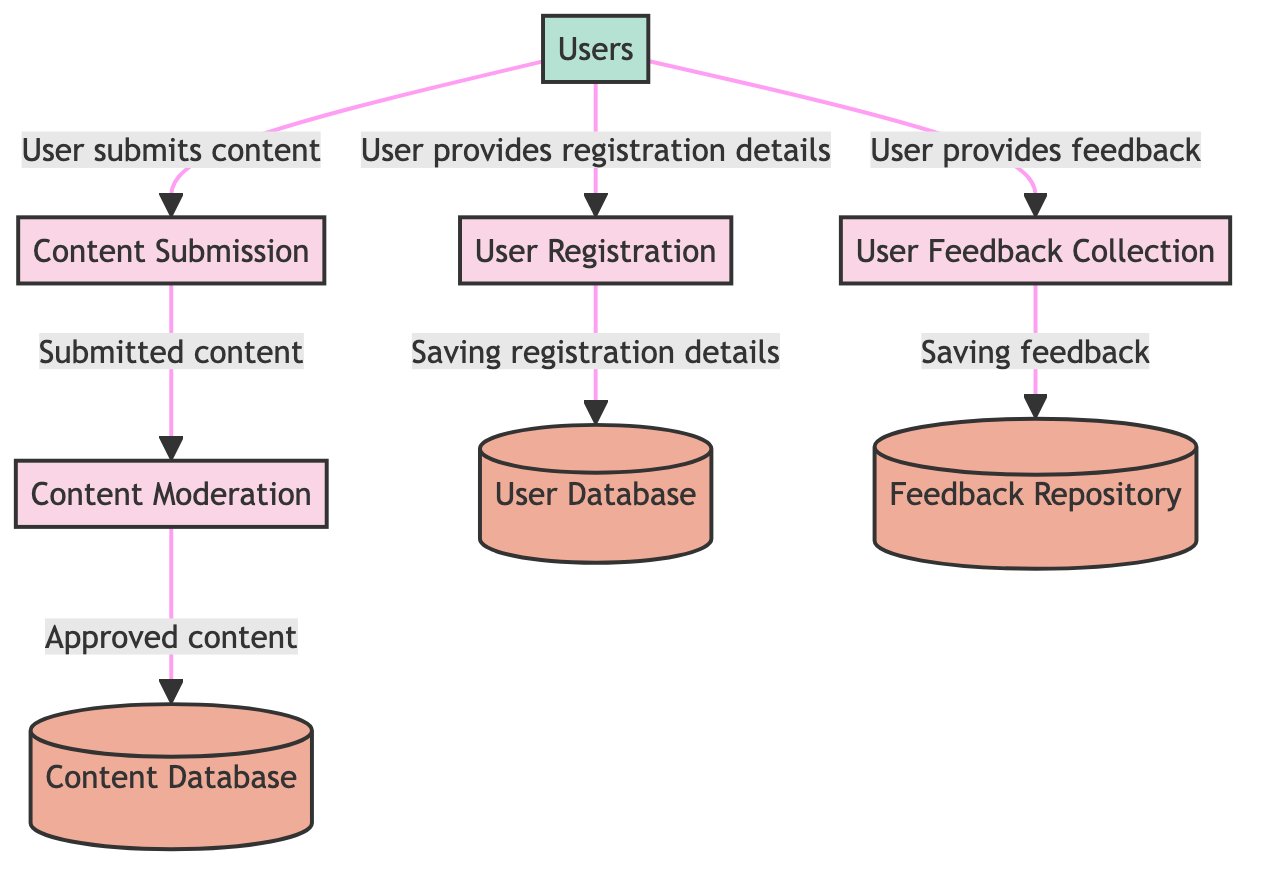What is the first process to occur in the diagram? The diagram starts with the "User Registration" process, which is the first action taken by new users who want to join the community. It is labeled as process 1 in the diagram.
Answer: User Registration How many data stores are present in the diagram? The diagram features three distinct data stores: User Database, Content Database, and Feedback Repository. This is identified by counting the labeled data store nodes.
Answer: 3 What flow represents the approval of content? The flow from "Content Moderation" to "Content Database" signifies the approval of content, where the moderated content gets stored once approved. This is indicated by the connection between these two processes in the diagram.
Answer: Approved content What type of information does the User Database store? The User Database stores user registration details, including usernames, passwords, emails, and profiles, as described in the data store section of the diagram.
Answer: User registration details What is the source of feedback collected in the User Feedback Collection process? The source of feedback in the "User Feedback Collection" process is the users, as they provide feedback directly into this process. This is indicated by the flow originating from the "Users" node leading to the process.
Answer: Users What happens to submitted content after it is moderated? After the content is moderated, it is saved to the "Content Database," which indicates that the moderated content becomes part of the structured data stored in the system. This is shown by the flow directed from "Content Moderation" to "Content Database."
Answer: Saved to Content Database How does the diagram categorize users who interact with the system? Users are categorized as an external entity in the diagram, specifically referred to as "Users," which is indicated in the External Entities section and shows how they interact with various processes.
Answer: External entity What action must a user take before submitting content? A user must first complete the "User Registration" process in order to join the community and gain permission to submit content; this is inferred from the diagram's flow that indicates registration is a prerequisite.
Answer: User Registration What is stored in the Feedback Repository? The Feedback Repository is used to store user feedback and suggestions, which is explicitly mentioned in the description of the feedback data store within the diagram.
Answer: User feedback and suggestions 